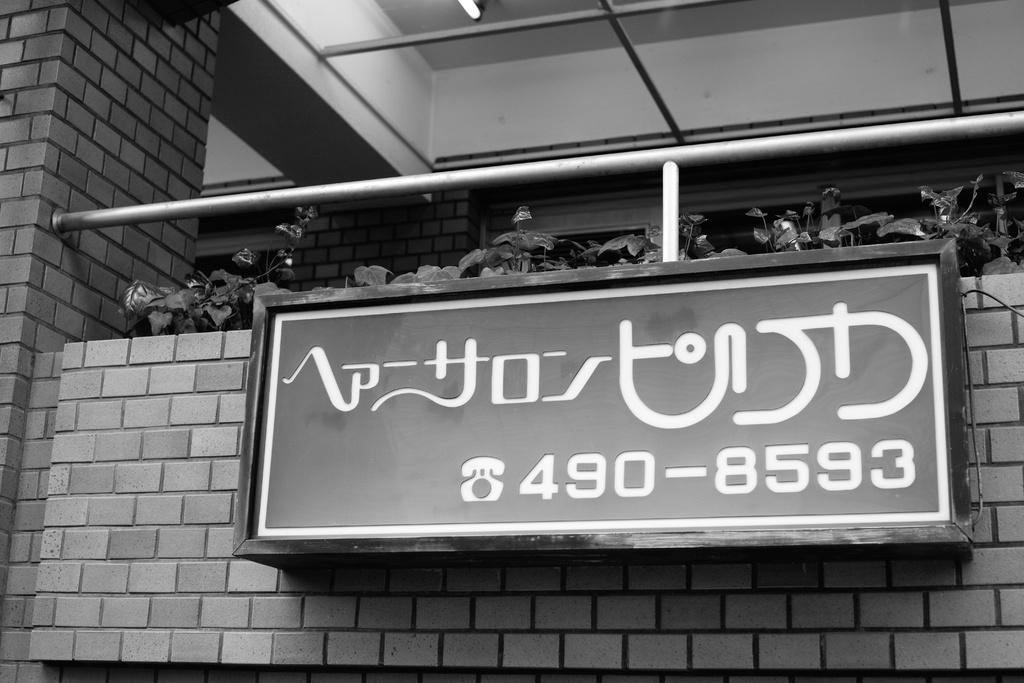What is located in the foreground of the picture? There is a board in the foreground of the picture. What structure is visible behind the board? There is a building behind the board. What type of vegetation is present in the picture? There are plants in the center of the picture. What can be seen at the top of the picture? There is a light visible at the top of the picture. Are there any police officers wearing masks in the picture? There is no indication of police officers or masks in the image; it features a board, a building, plants, and a light. Can you describe the haircut of the person in the picture? There is no person present in the image, so it is not possible to describe their haircut. 